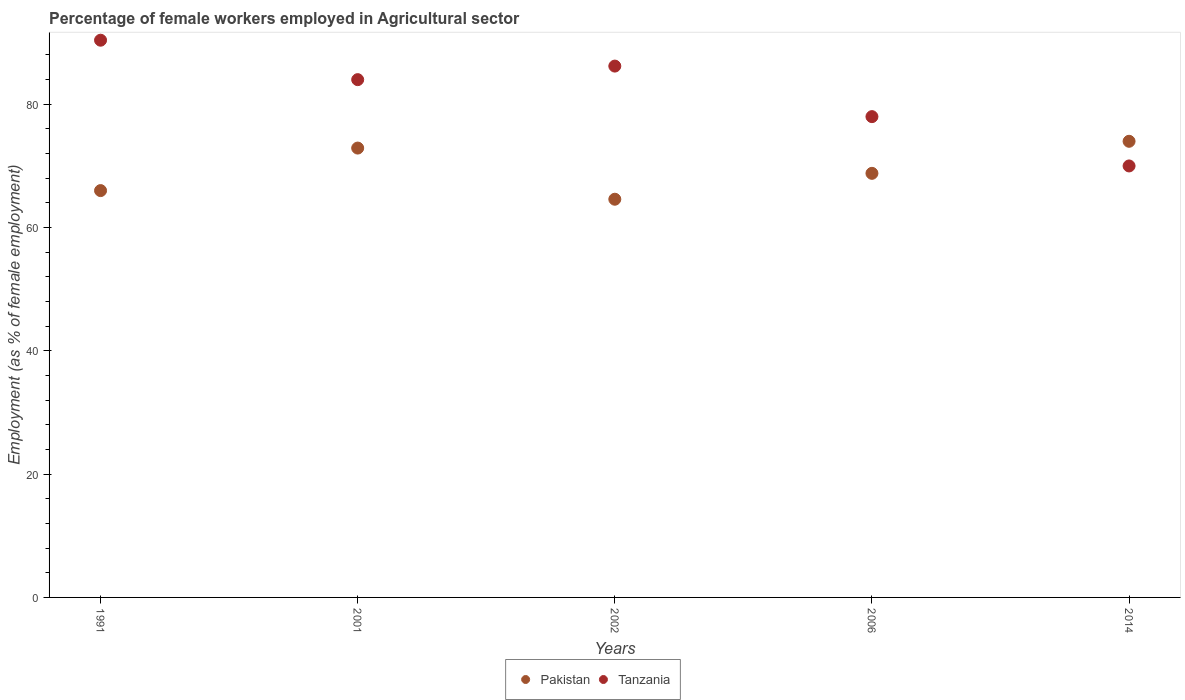What is the percentage of females employed in Agricultural sector in Pakistan in 2002?
Offer a terse response. 64.6. Across all years, what is the maximum percentage of females employed in Agricultural sector in Tanzania?
Your response must be concise. 90.4. In which year was the percentage of females employed in Agricultural sector in Pakistan minimum?
Your answer should be compact. 2002. What is the total percentage of females employed in Agricultural sector in Tanzania in the graph?
Provide a succinct answer. 408.6. What is the difference between the percentage of females employed in Agricultural sector in Tanzania in 2006 and that in 2014?
Keep it short and to the point. 8. What is the difference between the percentage of females employed in Agricultural sector in Tanzania in 2002 and the percentage of females employed in Agricultural sector in Pakistan in 2014?
Your response must be concise. 12.2. What is the average percentage of females employed in Agricultural sector in Tanzania per year?
Your response must be concise. 81.72. In the year 2006, what is the difference between the percentage of females employed in Agricultural sector in Pakistan and percentage of females employed in Agricultural sector in Tanzania?
Keep it short and to the point. -9.2. In how many years, is the percentage of females employed in Agricultural sector in Tanzania greater than 4 %?
Your response must be concise. 5. What is the ratio of the percentage of females employed in Agricultural sector in Pakistan in 1991 to that in 2014?
Keep it short and to the point. 0.89. Is the difference between the percentage of females employed in Agricultural sector in Pakistan in 1991 and 2001 greater than the difference between the percentage of females employed in Agricultural sector in Tanzania in 1991 and 2001?
Offer a very short reply. No. What is the difference between the highest and the second highest percentage of females employed in Agricultural sector in Pakistan?
Make the answer very short. 1.1. What is the difference between the highest and the lowest percentage of females employed in Agricultural sector in Pakistan?
Provide a succinct answer. 9.4. Does the percentage of females employed in Agricultural sector in Pakistan monotonically increase over the years?
Your answer should be compact. No. Is the percentage of females employed in Agricultural sector in Tanzania strictly greater than the percentage of females employed in Agricultural sector in Pakistan over the years?
Make the answer very short. No. Is the percentage of females employed in Agricultural sector in Pakistan strictly less than the percentage of females employed in Agricultural sector in Tanzania over the years?
Provide a short and direct response. No. How many dotlines are there?
Ensure brevity in your answer.  2. Are the values on the major ticks of Y-axis written in scientific E-notation?
Your answer should be compact. No. Does the graph contain any zero values?
Provide a short and direct response. No. How are the legend labels stacked?
Keep it short and to the point. Horizontal. What is the title of the graph?
Keep it short and to the point. Percentage of female workers employed in Agricultural sector. What is the label or title of the Y-axis?
Ensure brevity in your answer.  Employment (as % of female employment). What is the Employment (as % of female employment) of Pakistan in 1991?
Offer a terse response. 66. What is the Employment (as % of female employment) of Tanzania in 1991?
Offer a very short reply. 90.4. What is the Employment (as % of female employment) in Pakistan in 2001?
Give a very brief answer. 72.9. What is the Employment (as % of female employment) in Pakistan in 2002?
Ensure brevity in your answer.  64.6. What is the Employment (as % of female employment) in Tanzania in 2002?
Offer a terse response. 86.2. What is the Employment (as % of female employment) of Pakistan in 2006?
Make the answer very short. 68.8. What is the Employment (as % of female employment) in Tanzania in 2014?
Provide a succinct answer. 70. Across all years, what is the maximum Employment (as % of female employment) of Pakistan?
Give a very brief answer. 74. Across all years, what is the maximum Employment (as % of female employment) of Tanzania?
Offer a terse response. 90.4. Across all years, what is the minimum Employment (as % of female employment) in Pakistan?
Make the answer very short. 64.6. Across all years, what is the minimum Employment (as % of female employment) of Tanzania?
Provide a succinct answer. 70. What is the total Employment (as % of female employment) of Pakistan in the graph?
Provide a short and direct response. 346.3. What is the total Employment (as % of female employment) in Tanzania in the graph?
Make the answer very short. 408.6. What is the difference between the Employment (as % of female employment) in Pakistan in 1991 and that in 2001?
Make the answer very short. -6.9. What is the difference between the Employment (as % of female employment) in Tanzania in 1991 and that in 2002?
Your response must be concise. 4.2. What is the difference between the Employment (as % of female employment) in Pakistan in 1991 and that in 2006?
Keep it short and to the point. -2.8. What is the difference between the Employment (as % of female employment) in Tanzania in 1991 and that in 2014?
Provide a succinct answer. 20.4. What is the difference between the Employment (as % of female employment) in Pakistan in 2001 and that in 2002?
Ensure brevity in your answer.  8.3. What is the difference between the Employment (as % of female employment) in Tanzania in 2001 and that in 2002?
Provide a succinct answer. -2.2. What is the difference between the Employment (as % of female employment) of Pakistan in 2001 and that in 2006?
Your response must be concise. 4.1. What is the difference between the Employment (as % of female employment) in Tanzania in 2002 and that in 2006?
Offer a very short reply. 8.2. What is the difference between the Employment (as % of female employment) of Pakistan in 2002 and that in 2014?
Provide a succinct answer. -9.4. What is the difference between the Employment (as % of female employment) in Tanzania in 2002 and that in 2014?
Offer a very short reply. 16.2. What is the difference between the Employment (as % of female employment) of Tanzania in 2006 and that in 2014?
Keep it short and to the point. 8. What is the difference between the Employment (as % of female employment) in Pakistan in 1991 and the Employment (as % of female employment) in Tanzania in 2001?
Your response must be concise. -18. What is the difference between the Employment (as % of female employment) of Pakistan in 1991 and the Employment (as % of female employment) of Tanzania in 2002?
Keep it short and to the point. -20.2. What is the difference between the Employment (as % of female employment) of Pakistan in 1991 and the Employment (as % of female employment) of Tanzania in 2006?
Give a very brief answer. -12. What is the difference between the Employment (as % of female employment) of Pakistan in 1991 and the Employment (as % of female employment) of Tanzania in 2014?
Your answer should be compact. -4. What is the difference between the Employment (as % of female employment) of Pakistan in 2001 and the Employment (as % of female employment) of Tanzania in 2002?
Your answer should be compact. -13.3. What is the difference between the Employment (as % of female employment) of Pakistan in 2001 and the Employment (as % of female employment) of Tanzania in 2014?
Make the answer very short. 2.9. What is the difference between the Employment (as % of female employment) of Pakistan in 2002 and the Employment (as % of female employment) of Tanzania in 2014?
Make the answer very short. -5.4. What is the difference between the Employment (as % of female employment) in Pakistan in 2006 and the Employment (as % of female employment) in Tanzania in 2014?
Provide a short and direct response. -1.2. What is the average Employment (as % of female employment) of Pakistan per year?
Ensure brevity in your answer.  69.26. What is the average Employment (as % of female employment) in Tanzania per year?
Your answer should be compact. 81.72. In the year 1991, what is the difference between the Employment (as % of female employment) in Pakistan and Employment (as % of female employment) in Tanzania?
Make the answer very short. -24.4. In the year 2002, what is the difference between the Employment (as % of female employment) of Pakistan and Employment (as % of female employment) of Tanzania?
Offer a very short reply. -21.6. In the year 2006, what is the difference between the Employment (as % of female employment) of Pakistan and Employment (as % of female employment) of Tanzania?
Your answer should be very brief. -9.2. In the year 2014, what is the difference between the Employment (as % of female employment) in Pakistan and Employment (as % of female employment) in Tanzania?
Ensure brevity in your answer.  4. What is the ratio of the Employment (as % of female employment) in Pakistan in 1991 to that in 2001?
Your response must be concise. 0.91. What is the ratio of the Employment (as % of female employment) in Tanzania in 1991 to that in 2001?
Provide a short and direct response. 1.08. What is the ratio of the Employment (as % of female employment) of Pakistan in 1991 to that in 2002?
Your answer should be very brief. 1.02. What is the ratio of the Employment (as % of female employment) in Tanzania in 1991 to that in 2002?
Keep it short and to the point. 1.05. What is the ratio of the Employment (as % of female employment) of Pakistan in 1991 to that in 2006?
Offer a terse response. 0.96. What is the ratio of the Employment (as % of female employment) of Tanzania in 1991 to that in 2006?
Give a very brief answer. 1.16. What is the ratio of the Employment (as % of female employment) in Pakistan in 1991 to that in 2014?
Provide a succinct answer. 0.89. What is the ratio of the Employment (as % of female employment) in Tanzania in 1991 to that in 2014?
Make the answer very short. 1.29. What is the ratio of the Employment (as % of female employment) in Pakistan in 2001 to that in 2002?
Give a very brief answer. 1.13. What is the ratio of the Employment (as % of female employment) in Tanzania in 2001 to that in 2002?
Make the answer very short. 0.97. What is the ratio of the Employment (as % of female employment) of Pakistan in 2001 to that in 2006?
Offer a terse response. 1.06. What is the ratio of the Employment (as % of female employment) of Pakistan in 2001 to that in 2014?
Your answer should be compact. 0.99. What is the ratio of the Employment (as % of female employment) in Pakistan in 2002 to that in 2006?
Keep it short and to the point. 0.94. What is the ratio of the Employment (as % of female employment) in Tanzania in 2002 to that in 2006?
Offer a very short reply. 1.11. What is the ratio of the Employment (as % of female employment) of Pakistan in 2002 to that in 2014?
Offer a very short reply. 0.87. What is the ratio of the Employment (as % of female employment) of Tanzania in 2002 to that in 2014?
Ensure brevity in your answer.  1.23. What is the ratio of the Employment (as % of female employment) of Pakistan in 2006 to that in 2014?
Keep it short and to the point. 0.93. What is the ratio of the Employment (as % of female employment) of Tanzania in 2006 to that in 2014?
Provide a succinct answer. 1.11. What is the difference between the highest and the lowest Employment (as % of female employment) of Tanzania?
Ensure brevity in your answer.  20.4. 